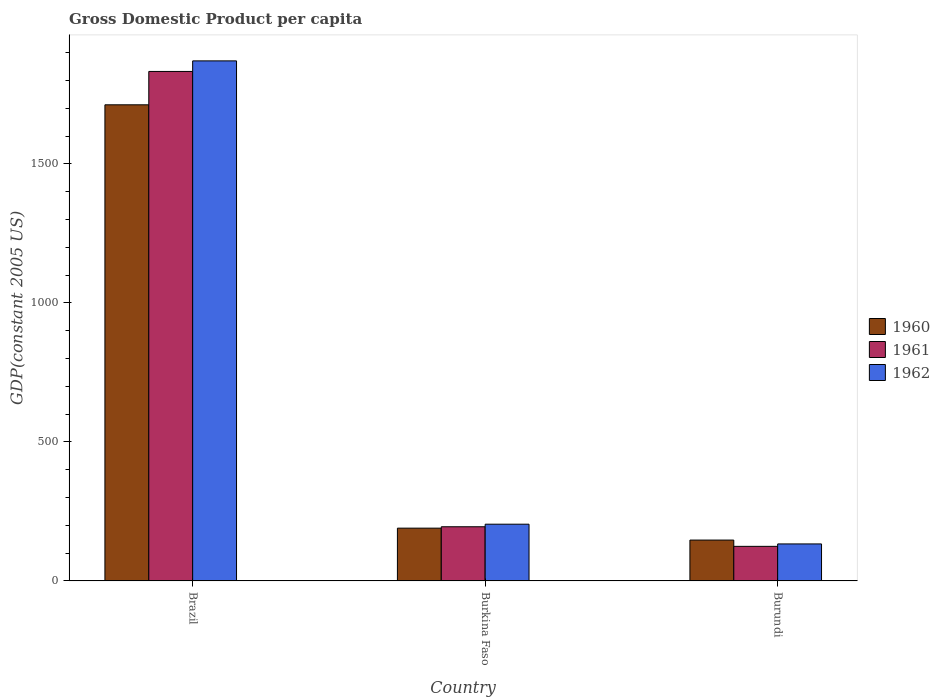How many groups of bars are there?
Your answer should be very brief. 3. What is the label of the 2nd group of bars from the left?
Your answer should be very brief. Burkina Faso. What is the GDP per capita in 1961 in Burundi?
Provide a succinct answer. 124.4. Across all countries, what is the maximum GDP per capita in 1961?
Your answer should be compact. 1832.81. Across all countries, what is the minimum GDP per capita in 1961?
Your response must be concise. 124.4. In which country was the GDP per capita in 1961 minimum?
Your response must be concise. Burundi. What is the total GDP per capita in 1961 in the graph?
Your response must be concise. 2152.14. What is the difference between the GDP per capita in 1961 in Brazil and that in Burundi?
Provide a short and direct response. 1708.4. What is the difference between the GDP per capita in 1960 in Burundi and the GDP per capita in 1962 in Brazil?
Your response must be concise. -1723.79. What is the average GDP per capita in 1962 per country?
Make the answer very short. 736.02. What is the difference between the GDP per capita of/in 1961 and GDP per capita of/in 1960 in Burundi?
Ensure brevity in your answer.  -22.6. In how many countries, is the GDP per capita in 1962 greater than 1300 US$?
Give a very brief answer. 1. What is the ratio of the GDP per capita in 1960 in Burkina Faso to that in Burundi?
Give a very brief answer. 1.29. Is the difference between the GDP per capita in 1961 in Brazil and Burkina Faso greater than the difference between the GDP per capita in 1960 in Brazil and Burkina Faso?
Offer a terse response. Yes. What is the difference between the highest and the second highest GDP per capita in 1961?
Your answer should be very brief. 1637.88. What is the difference between the highest and the lowest GDP per capita in 1961?
Make the answer very short. 1708.4. In how many countries, is the GDP per capita in 1960 greater than the average GDP per capita in 1960 taken over all countries?
Your response must be concise. 1. Is the sum of the GDP per capita in 1961 in Burkina Faso and Burundi greater than the maximum GDP per capita in 1962 across all countries?
Offer a very short reply. No. What does the 2nd bar from the right in Burundi represents?
Keep it short and to the point. 1961. How many bars are there?
Your answer should be compact. 9. Are all the bars in the graph horizontal?
Ensure brevity in your answer.  No. Does the graph contain any zero values?
Provide a succinct answer. No. Where does the legend appear in the graph?
Your answer should be very brief. Center right. How many legend labels are there?
Your answer should be very brief. 3. What is the title of the graph?
Your answer should be very brief. Gross Domestic Product per capita. Does "2002" appear as one of the legend labels in the graph?
Give a very brief answer. No. What is the label or title of the Y-axis?
Ensure brevity in your answer.  GDP(constant 2005 US). What is the GDP(constant 2005 US) in 1960 in Brazil?
Offer a very short reply. 1712.76. What is the GDP(constant 2005 US) in 1961 in Brazil?
Offer a very short reply. 1832.81. What is the GDP(constant 2005 US) in 1962 in Brazil?
Give a very brief answer. 1870.8. What is the GDP(constant 2005 US) of 1960 in Burkina Faso?
Give a very brief answer. 189.88. What is the GDP(constant 2005 US) of 1961 in Burkina Faso?
Make the answer very short. 194.93. What is the GDP(constant 2005 US) of 1962 in Burkina Faso?
Your answer should be very brief. 204.13. What is the GDP(constant 2005 US) of 1960 in Burundi?
Provide a short and direct response. 147.01. What is the GDP(constant 2005 US) of 1961 in Burundi?
Give a very brief answer. 124.4. What is the GDP(constant 2005 US) of 1962 in Burundi?
Ensure brevity in your answer.  133.14. Across all countries, what is the maximum GDP(constant 2005 US) of 1960?
Provide a short and direct response. 1712.76. Across all countries, what is the maximum GDP(constant 2005 US) of 1961?
Your answer should be compact. 1832.81. Across all countries, what is the maximum GDP(constant 2005 US) of 1962?
Provide a short and direct response. 1870.8. Across all countries, what is the minimum GDP(constant 2005 US) of 1960?
Give a very brief answer. 147.01. Across all countries, what is the minimum GDP(constant 2005 US) in 1961?
Offer a terse response. 124.4. Across all countries, what is the minimum GDP(constant 2005 US) in 1962?
Your response must be concise. 133.14. What is the total GDP(constant 2005 US) in 1960 in the graph?
Keep it short and to the point. 2049.65. What is the total GDP(constant 2005 US) in 1961 in the graph?
Keep it short and to the point. 2152.14. What is the total GDP(constant 2005 US) in 1962 in the graph?
Provide a short and direct response. 2208.07. What is the difference between the GDP(constant 2005 US) in 1960 in Brazil and that in Burkina Faso?
Make the answer very short. 1522.88. What is the difference between the GDP(constant 2005 US) in 1961 in Brazil and that in Burkina Faso?
Keep it short and to the point. 1637.88. What is the difference between the GDP(constant 2005 US) in 1962 in Brazil and that in Burkina Faso?
Provide a succinct answer. 1666.67. What is the difference between the GDP(constant 2005 US) in 1960 in Brazil and that in Burundi?
Provide a short and direct response. 1565.76. What is the difference between the GDP(constant 2005 US) of 1961 in Brazil and that in Burundi?
Offer a terse response. 1708.4. What is the difference between the GDP(constant 2005 US) of 1962 in Brazil and that in Burundi?
Offer a very short reply. 1737.65. What is the difference between the GDP(constant 2005 US) in 1960 in Burkina Faso and that in Burundi?
Offer a very short reply. 42.88. What is the difference between the GDP(constant 2005 US) of 1961 in Burkina Faso and that in Burundi?
Your answer should be very brief. 70.52. What is the difference between the GDP(constant 2005 US) of 1962 in Burkina Faso and that in Burundi?
Offer a very short reply. 70.99. What is the difference between the GDP(constant 2005 US) of 1960 in Brazil and the GDP(constant 2005 US) of 1961 in Burkina Faso?
Make the answer very short. 1517.84. What is the difference between the GDP(constant 2005 US) of 1960 in Brazil and the GDP(constant 2005 US) of 1962 in Burkina Faso?
Offer a terse response. 1508.63. What is the difference between the GDP(constant 2005 US) in 1961 in Brazil and the GDP(constant 2005 US) in 1962 in Burkina Faso?
Offer a very short reply. 1628.68. What is the difference between the GDP(constant 2005 US) of 1960 in Brazil and the GDP(constant 2005 US) of 1961 in Burundi?
Provide a short and direct response. 1588.36. What is the difference between the GDP(constant 2005 US) in 1960 in Brazil and the GDP(constant 2005 US) in 1962 in Burundi?
Offer a terse response. 1579.62. What is the difference between the GDP(constant 2005 US) of 1961 in Brazil and the GDP(constant 2005 US) of 1962 in Burundi?
Offer a very short reply. 1699.67. What is the difference between the GDP(constant 2005 US) in 1960 in Burkina Faso and the GDP(constant 2005 US) in 1961 in Burundi?
Give a very brief answer. 65.48. What is the difference between the GDP(constant 2005 US) of 1960 in Burkina Faso and the GDP(constant 2005 US) of 1962 in Burundi?
Offer a very short reply. 56.74. What is the difference between the GDP(constant 2005 US) of 1961 in Burkina Faso and the GDP(constant 2005 US) of 1962 in Burundi?
Provide a succinct answer. 61.78. What is the average GDP(constant 2005 US) of 1960 per country?
Offer a terse response. 683.22. What is the average GDP(constant 2005 US) in 1961 per country?
Your answer should be very brief. 717.38. What is the average GDP(constant 2005 US) in 1962 per country?
Give a very brief answer. 736.02. What is the difference between the GDP(constant 2005 US) in 1960 and GDP(constant 2005 US) in 1961 in Brazil?
Provide a succinct answer. -120.04. What is the difference between the GDP(constant 2005 US) in 1960 and GDP(constant 2005 US) in 1962 in Brazil?
Make the answer very short. -158.03. What is the difference between the GDP(constant 2005 US) in 1961 and GDP(constant 2005 US) in 1962 in Brazil?
Ensure brevity in your answer.  -37.99. What is the difference between the GDP(constant 2005 US) in 1960 and GDP(constant 2005 US) in 1961 in Burkina Faso?
Provide a succinct answer. -5.04. What is the difference between the GDP(constant 2005 US) of 1960 and GDP(constant 2005 US) of 1962 in Burkina Faso?
Your answer should be very brief. -14.25. What is the difference between the GDP(constant 2005 US) of 1961 and GDP(constant 2005 US) of 1962 in Burkina Faso?
Offer a very short reply. -9.2. What is the difference between the GDP(constant 2005 US) of 1960 and GDP(constant 2005 US) of 1961 in Burundi?
Make the answer very short. 22.6. What is the difference between the GDP(constant 2005 US) in 1960 and GDP(constant 2005 US) in 1962 in Burundi?
Offer a very short reply. 13.86. What is the difference between the GDP(constant 2005 US) in 1961 and GDP(constant 2005 US) in 1962 in Burundi?
Provide a short and direct response. -8.74. What is the ratio of the GDP(constant 2005 US) of 1960 in Brazil to that in Burkina Faso?
Your answer should be very brief. 9.02. What is the ratio of the GDP(constant 2005 US) of 1961 in Brazil to that in Burkina Faso?
Provide a short and direct response. 9.4. What is the ratio of the GDP(constant 2005 US) in 1962 in Brazil to that in Burkina Faso?
Offer a very short reply. 9.16. What is the ratio of the GDP(constant 2005 US) in 1960 in Brazil to that in Burundi?
Your response must be concise. 11.65. What is the ratio of the GDP(constant 2005 US) in 1961 in Brazil to that in Burundi?
Offer a very short reply. 14.73. What is the ratio of the GDP(constant 2005 US) in 1962 in Brazil to that in Burundi?
Offer a terse response. 14.05. What is the ratio of the GDP(constant 2005 US) of 1960 in Burkina Faso to that in Burundi?
Make the answer very short. 1.29. What is the ratio of the GDP(constant 2005 US) of 1961 in Burkina Faso to that in Burundi?
Offer a very short reply. 1.57. What is the ratio of the GDP(constant 2005 US) of 1962 in Burkina Faso to that in Burundi?
Provide a succinct answer. 1.53. What is the difference between the highest and the second highest GDP(constant 2005 US) in 1960?
Offer a very short reply. 1522.88. What is the difference between the highest and the second highest GDP(constant 2005 US) of 1961?
Provide a short and direct response. 1637.88. What is the difference between the highest and the second highest GDP(constant 2005 US) of 1962?
Your answer should be compact. 1666.67. What is the difference between the highest and the lowest GDP(constant 2005 US) of 1960?
Give a very brief answer. 1565.76. What is the difference between the highest and the lowest GDP(constant 2005 US) of 1961?
Ensure brevity in your answer.  1708.4. What is the difference between the highest and the lowest GDP(constant 2005 US) in 1962?
Provide a short and direct response. 1737.65. 